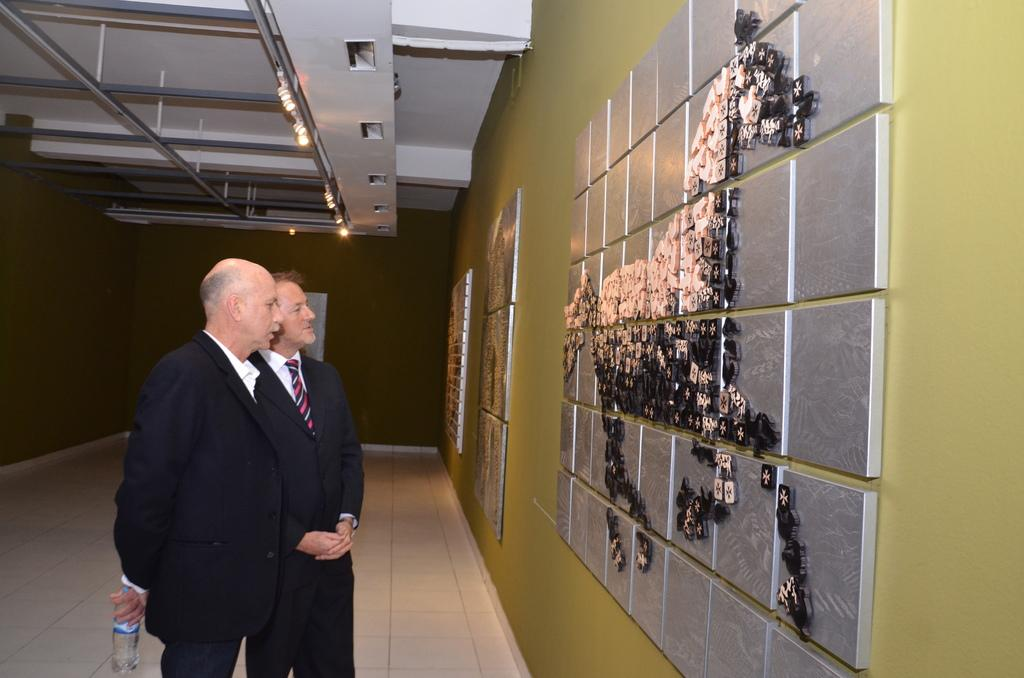How many people are in the image? There are two persons in the image. What is one of the persons holding? One of the persons is holding a bottle. What can be seen in the image that provides illumination? There are lights in the image. What is located above the people in the image? There is a roof in the image. What type of decoration is present on the wall in the image? There is art on the wall in the image. What type of discussion is taking place between the band members in the image? There is no band present in the image, and therefore no discussion between band members can be observed. What color is the silver object on the table in the image? There is no silver object present in the image. 